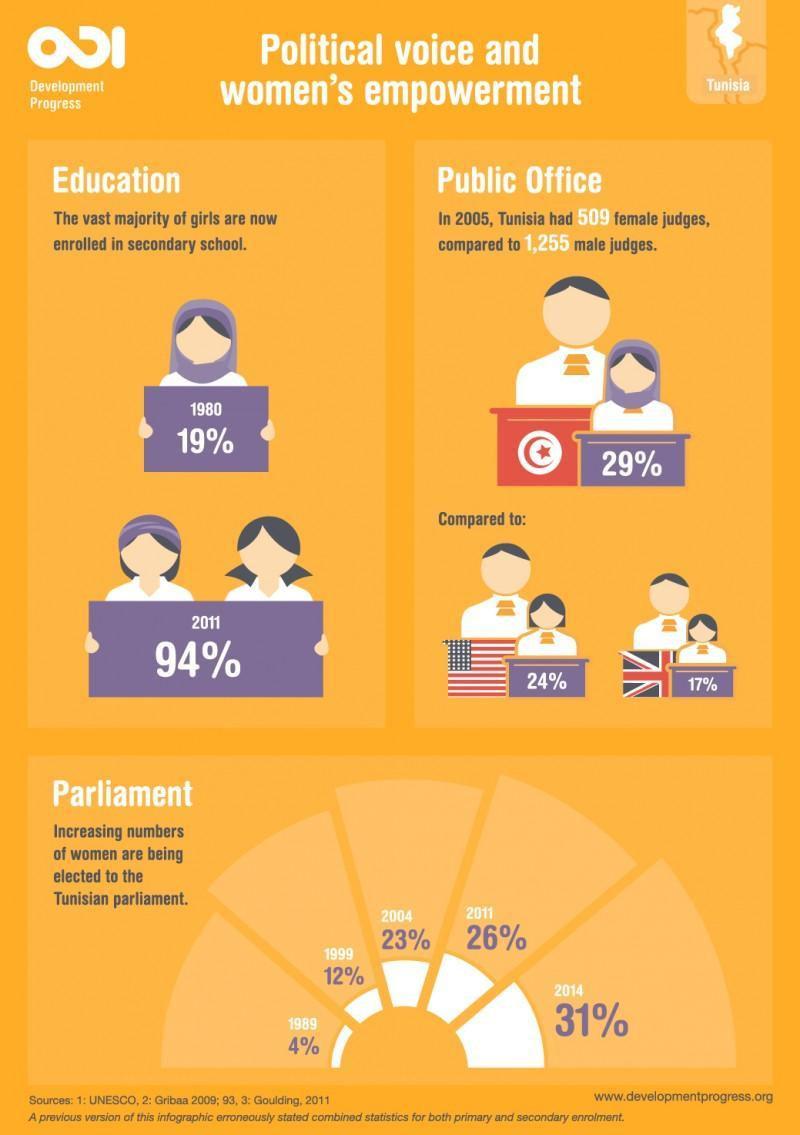What % of girls have not  been enrolled in  2011
Answer the question with a short phrase. 6 What is the % of female judges in UK 17% What has been the % increase of female enrollment in secondary school in 2011 when compared to 1980 75 What is the % of female judges in US 24% What has been the % increase in the number of women being elected to the Tunisian Parliament in 2014 when compared to 1989 27 What is the % of female judges in Tunisia 29% 